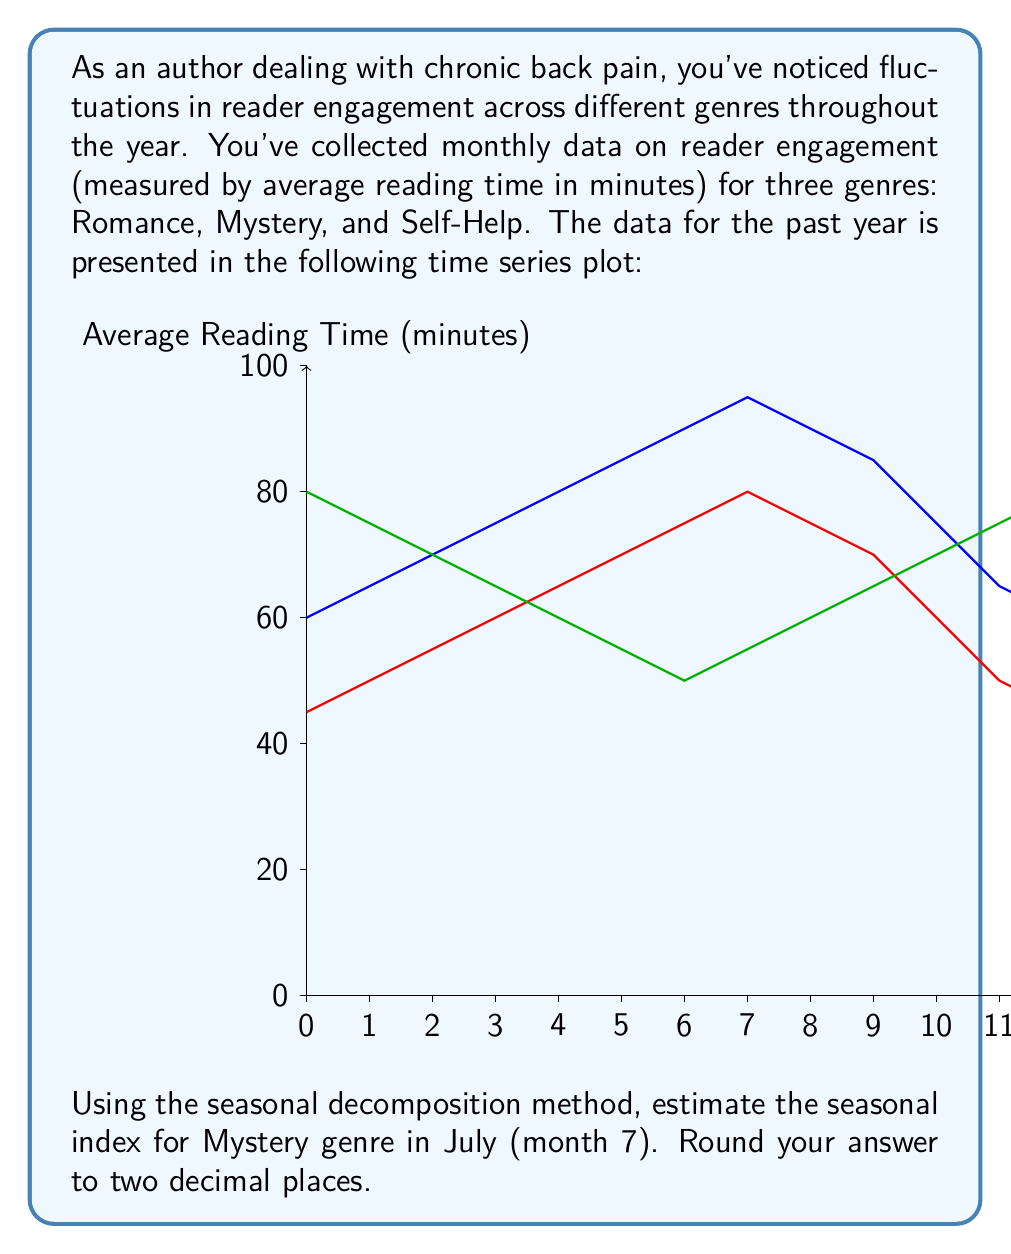Can you answer this question? To estimate the seasonal index for the Mystery genre in July, we'll follow these steps:

1) First, we need to calculate the centered moving average (CMA) to remove the seasonal component. For a 12-month cycle:

   $$CMA_t = \frac{1}{24}(0.5Y_{t-6} + Y_{t-5} + ... + Y_t + ... + Y_{t+5} + 0.5Y_{t+6})$$

2) We don't have enough data to calculate the CMA for all months, so we'll use the average of all data points as an approximation:

   $$CMA \approx \frac{60+65+70+75+80+85+90+95+90+85+75+65}{12} = 77.92$$

3) The seasonal-irregular component (SI) is obtained by dividing the original data by the CMA:

   $$SI_{\text{July}} = \frac{Y_{\text{July}}}{CMA} = \frac{90}{77.92} = 1.1550$$

4) To isolate the seasonal component, we average the SI values for each month across multiple years. Since we only have one year of data, we'll use the July SI as our seasonal index.

5) The seasonal index for Mystery genre in July is therefore 1.1550.

6) Rounding to two decimal places: 1.16
Answer: 1.16 